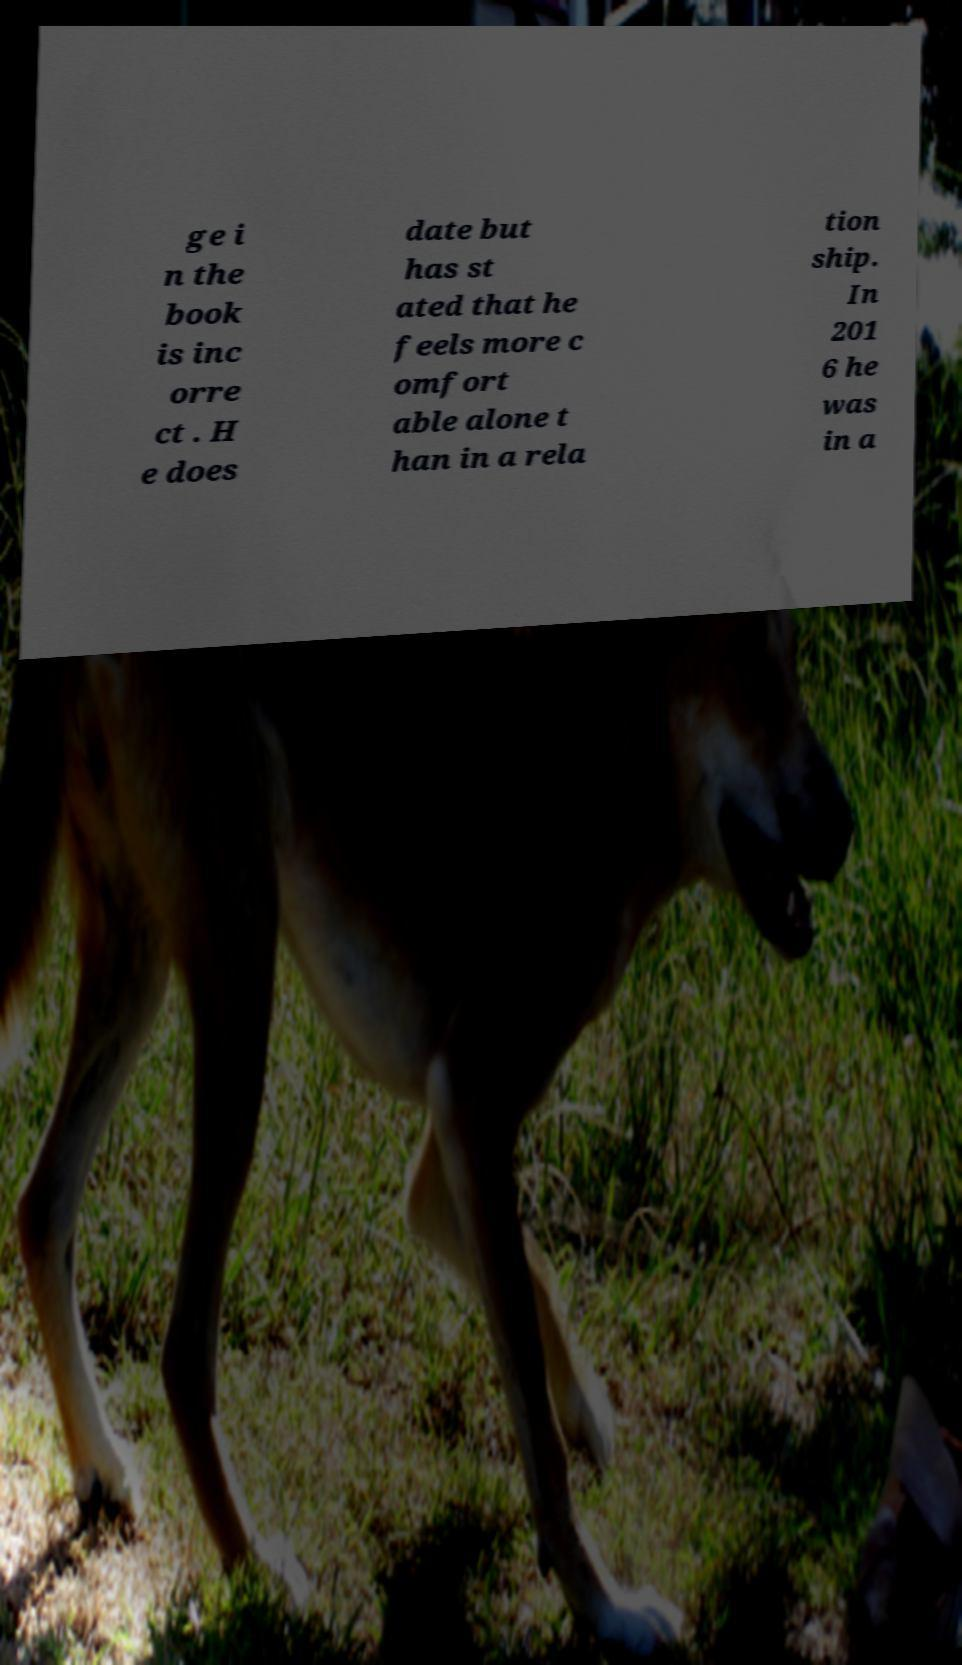Could you assist in decoding the text presented in this image and type it out clearly? ge i n the book is inc orre ct . H e does date but has st ated that he feels more c omfort able alone t han in a rela tion ship. In 201 6 he was in a 